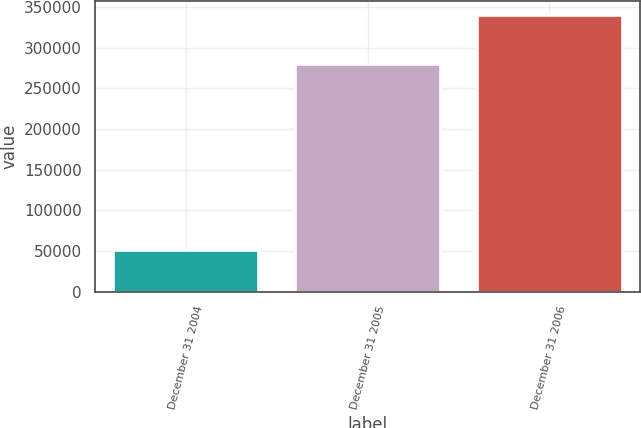Convert chart to OTSL. <chart><loc_0><loc_0><loc_500><loc_500><bar_chart><fcel>December 31 2004<fcel>December 31 2005<fcel>December 31 2006<nl><fcel>51206<fcel>279355<fcel>340253<nl></chart> 